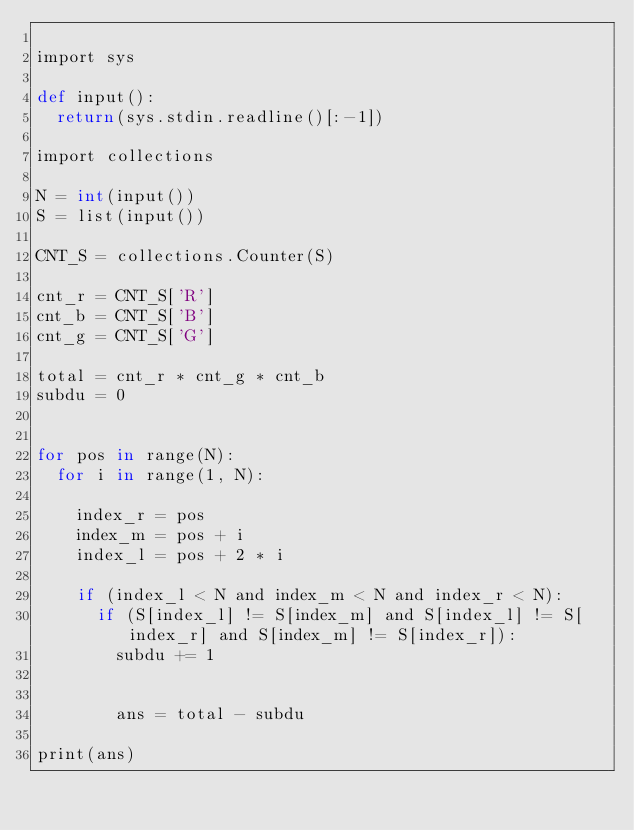Convert code to text. <code><loc_0><loc_0><loc_500><loc_500><_Cython_>
import sys

def input():
  return(sys.stdin.readline()[:-1])

import collections

N = int(input())
S = list(input())

CNT_S = collections.Counter(S)

cnt_r = CNT_S['R']
cnt_b = CNT_S['B']
cnt_g = CNT_S['G']

total = cnt_r * cnt_g * cnt_b
subdu = 0


for pos in range(N):
  for i in range(1, N):

    index_r = pos
    index_m = pos + i
    index_l = pos + 2 * i

    if (index_l < N and index_m < N and index_r < N):
      if (S[index_l] != S[index_m] and S[index_l] != S[index_r] and S[index_m] != S[index_r]):
        subdu += 1


        ans = total - subdu

print(ans)</code> 